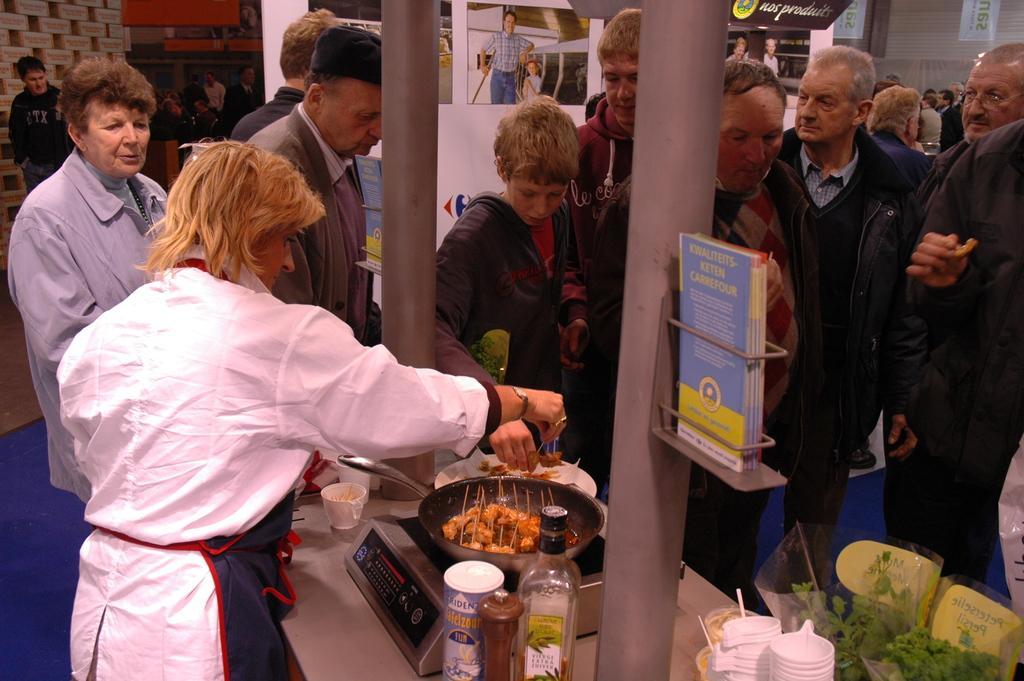Please provide a concise description of this image. In this image we can see many people. There is a platform. On that there is an induction stove. There are bottles. Also there is a pan with food item. There are cups and some leaves. There are pillars. On the pillar there is a stand with papers. In the background there are posters. 